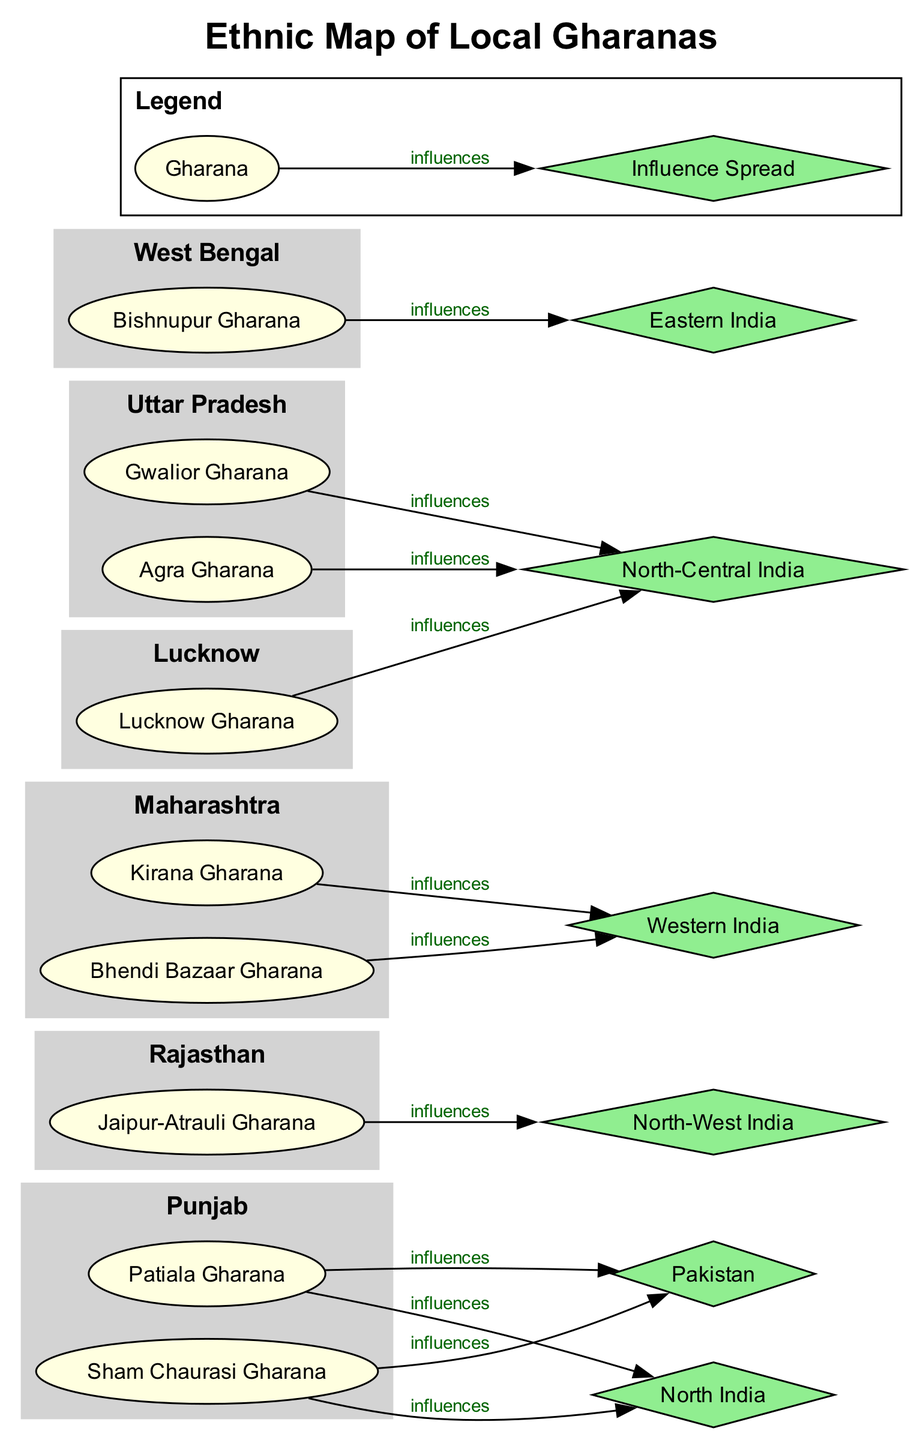What are the gharanas listed under Punjab? Under the region of Punjab, the gharanas are Patiala Gharana and Sham Chaurasi Gharana, which are directly represented as nodes in that regional subgraph.
Answer: Patiala Gharana, Sham Chaurasi Gharana How many gharanas are affiliated with Maharashtra? In the state of Maharashtra, there are two gharanas mentioned: Kirana Gharana and Bhendi Bazaar Gharana, which are explicitly included in the relevant subgraph. This answers the question of quantity directly.
Answer: 2 Which region is associated with the Bishnupur Gharana? The Bishnupur Gharana is explicitly located within the region of West Bengal, as indicated directly in the diagram under that regional subgraph.
Answer: West Bengal What regions does the Agra Gharana influence? The Agra Gharana influences North-Central India, which can be determined by its connection labeled "influences" from the gharana node to the influence spread node in the Uttar Pradesh subgraph.
Answer: North-Central India How many different regions are depicted in the diagram? By counting the listed regions within the ethnic map, there are six distinct regional subgraphs provided in the diagram, therefore answering the query about the diversity of areas represented.
Answer: 6 Which gharana influences Eastern India? The gharana that influences Eastern India, as shown in the diagram, is Bishnupur Gharana, which connects directly to the influence spread node labeled "Eastern India".
Answer: Bishnupur Gharana Which gharana is located in Rajasthan? The only gharana depicted in the region of Rajasthan is Jaipur-Atrauli Gharana, which can be easily pinpointed by looking at the corresponding regional subgraph labeled Rajasthan.
Answer: Jaipur-Atrauli Gharana How many regions influence North India? There are two regions that have connections to North India in the diagram: Punjab and Uttar Pradesh, which can be deduced by reviewing their respective influence spread nodes in the diagram.
Answer: 2 What is the legend's description of a gharana? The legend describes a gharana as "A style or genre of Indian classical music", which can be confirmed by referring to the legend section included in the diagram.
Answer: A style or genre of Indian classical music 